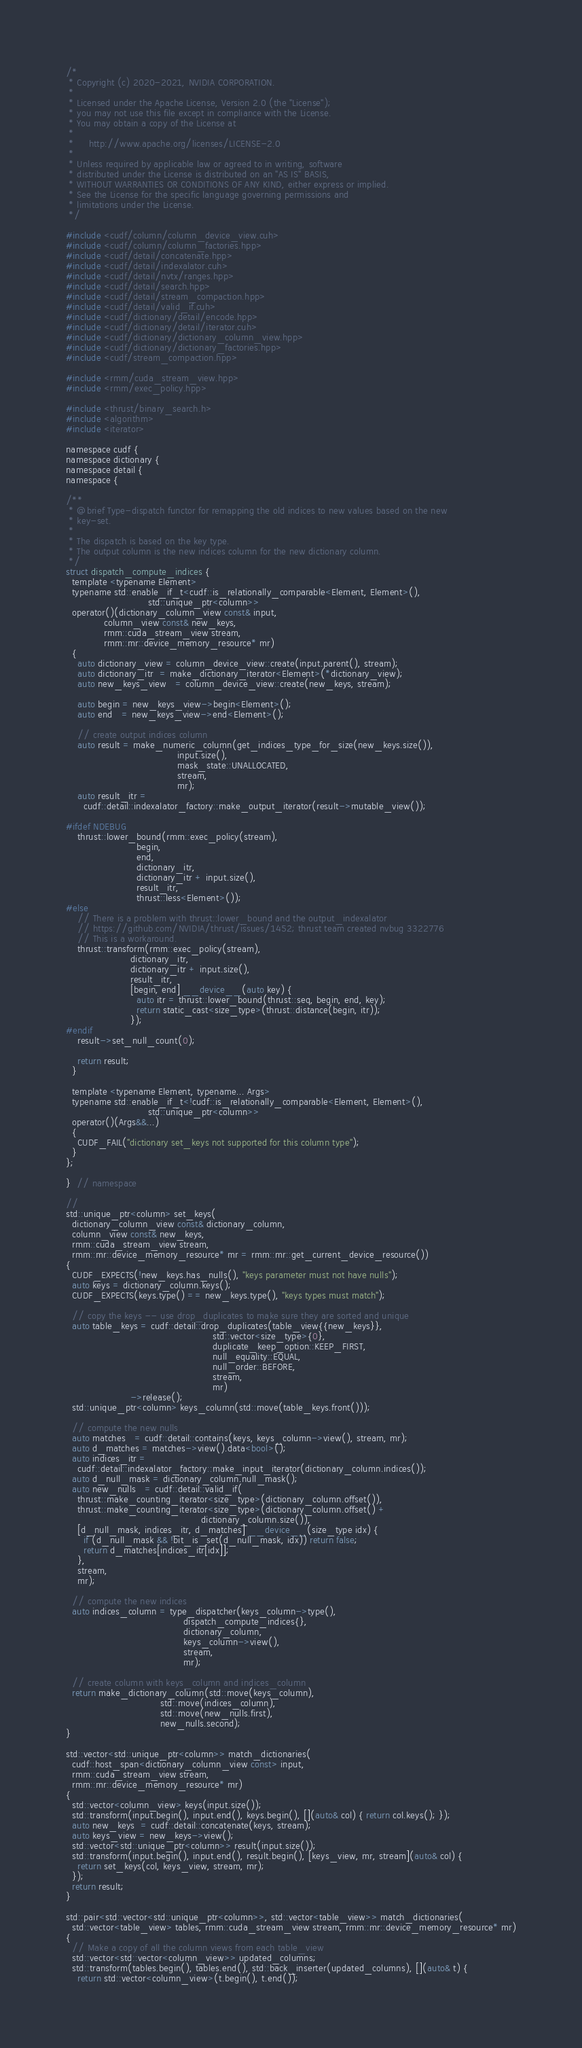<code> <loc_0><loc_0><loc_500><loc_500><_Cuda_>/*
 * Copyright (c) 2020-2021, NVIDIA CORPORATION.
 *
 * Licensed under the Apache License, Version 2.0 (the "License");
 * you may not use this file except in compliance with the License.
 * You may obtain a copy of the License at
 *
 *     http://www.apache.org/licenses/LICENSE-2.0
 *
 * Unless required by applicable law or agreed to in writing, software
 * distributed under the License is distributed on an "AS IS" BASIS,
 * WITHOUT WARRANTIES OR CONDITIONS OF ANY KIND, either express or implied.
 * See the License for the specific language governing permissions and
 * limitations under the License.
 */

#include <cudf/column/column_device_view.cuh>
#include <cudf/column/column_factories.hpp>
#include <cudf/detail/concatenate.hpp>
#include <cudf/detail/indexalator.cuh>
#include <cudf/detail/nvtx/ranges.hpp>
#include <cudf/detail/search.hpp>
#include <cudf/detail/stream_compaction.hpp>
#include <cudf/detail/valid_if.cuh>
#include <cudf/dictionary/detail/encode.hpp>
#include <cudf/dictionary/detail/iterator.cuh>
#include <cudf/dictionary/dictionary_column_view.hpp>
#include <cudf/dictionary/dictionary_factories.hpp>
#include <cudf/stream_compaction.hpp>

#include <rmm/cuda_stream_view.hpp>
#include <rmm/exec_policy.hpp>

#include <thrust/binary_search.h>
#include <algorithm>
#include <iterator>

namespace cudf {
namespace dictionary {
namespace detail {
namespace {

/**
 * @brief Type-dispatch functor for remapping the old indices to new values based on the new
 * key-set.
 *
 * The dispatch is based on the key type.
 * The output column is the new indices column for the new dictionary column.
 */
struct dispatch_compute_indices {
  template <typename Element>
  typename std::enable_if_t<cudf::is_relationally_comparable<Element, Element>(),
                            std::unique_ptr<column>>
  operator()(dictionary_column_view const& input,
             column_view const& new_keys,
             rmm::cuda_stream_view stream,
             rmm::mr::device_memory_resource* mr)
  {
    auto dictionary_view = column_device_view::create(input.parent(), stream);
    auto dictionary_itr  = make_dictionary_iterator<Element>(*dictionary_view);
    auto new_keys_view   = column_device_view::create(new_keys, stream);

    auto begin = new_keys_view->begin<Element>();
    auto end   = new_keys_view->end<Element>();

    // create output indices column
    auto result = make_numeric_column(get_indices_type_for_size(new_keys.size()),
                                      input.size(),
                                      mask_state::UNALLOCATED,
                                      stream,
                                      mr);
    auto result_itr =
      cudf::detail::indexalator_factory::make_output_iterator(result->mutable_view());

#ifdef NDEBUG
    thrust::lower_bound(rmm::exec_policy(stream),
                        begin,
                        end,
                        dictionary_itr,
                        dictionary_itr + input.size(),
                        result_itr,
                        thrust::less<Element>());
#else
    // There is a problem with thrust::lower_bound and the output_indexalator
    // https://github.com/NVIDIA/thrust/issues/1452; thrust team created nvbug 3322776
    // This is a workaround.
    thrust::transform(rmm::exec_policy(stream),
                      dictionary_itr,
                      dictionary_itr + input.size(),
                      result_itr,
                      [begin, end] __device__(auto key) {
                        auto itr = thrust::lower_bound(thrust::seq, begin, end, key);
                        return static_cast<size_type>(thrust::distance(begin, itr));
                      });
#endif
    result->set_null_count(0);

    return result;
  }

  template <typename Element, typename... Args>
  typename std::enable_if_t<!cudf::is_relationally_comparable<Element, Element>(),
                            std::unique_ptr<column>>
  operator()(Args&&...)
  {
    CUDF_FAIL("dictionary set_keys not supported for this column type");
  }
};

}  // namespace

//
std::unique_ptr<column> set_keys(
  dictionary_column_view const& dictionary_column,
  column_view const& new_keys,
  rmm::cuda_stream_view stream,
  rmm::mr::device_memory_resource* mr = rmm::mr::get_current_device_resource())
{
  CUDF_EXPECTS(!new_keys.has_nulls(), "keys parameter must not have nulls");
  auto keys = dictionary_column.keys();
  CUDF_EXPECTS(keys.type() == new_keys.type(), "keys types must match");

  // copy the keys -- use drop_duplicates to make sure they are sorted and unique
  auto table_keys = cudf::detail::drop_duplicates(table_view{{new_keys}},
                                                  std::vector<size_type>{0},
                                                  duplicate_keep_option::KEEP_FIRST,
                                                  null_equality::EQUAL,
                                                  null_order::BEFORE,
                                                  stream,
                                                  mr)
                      ->release();
  std::unique_ptr<column> keys_column(std::move(table_keys.front()));

  // compute the new nulls
  auto matches   = cudf::detail::contains(keys, keys_column->view(), stream, mr);
  auto d_matches = matches->view().data<bool>();
  auto indices_itr =
    cudf::detail::indexalator_factory::make_input_iterator(dictionary_column.indices());
  auto d_null_mask = dictionary_column.null_mask();
  auto new_nulls   = cudf::detail::valid_if(
    thrust::make_counting_iterator<size_type>(dictionary_column.offset()),
    thrust::make_counting_iterator<size_type>(dictionary_column.offset() +
                                              dictionary_column.size()),
    [d_null_mask, indices_itr, d_matches] __device__(size_type idx) {
      if (d_null_mask && !bit_is_set(d_null_mask, idx)) return false;
      return d_matches[indices_itr[idx]];
    },
    stream,
    mr);

  // compute the new indices
  auto indices_column = type_dispatcher(keys_column->type(),
                                        dispatch_compute_indices{},
                                        dictionary_column,
                                        keys_column->view(),
                                        stream,
                                        mr);

  // create column with keys_column and indices_column
  return make_dictionary_column(std::move(keys_column),
                                std::move(indices_column),
                                std::move(new_nulls.first),
                                new_nulls.second);
}

std::vector<std::unique_ptr<column>> match_dictionaries(
  cudf::host_span<dictionary_column_view const> input,
  rmm::cuda_stream_view stream,
  rmm::mr::device_memory_resource* mr)
{
  std::vector<column_view> keys(input.size());
  std::transform(input.begin(), input.end(), keys.begin(), [](auto& col) { return col.keys(); });
  auto new_keys  = cudf::detail::concatenate(keys, stream);
  auto keys_view = new_keys->view();
  std::vector<std::unique_ptr<column>> result(input.size());
  std::transform(input.begin(), input.end(), result.begin(), [keys_view, mr, stream](auto& col) {
    return set_keys(col, keys_view, stream, mr);
  });
  return result;
}

std::pair<std::vector<std::unique_ptr<column>>, std::vector<table_view>> match_dictionaries(
  std::vector<table_view> tables, rmm::cuda_stream_view stream, rmm::mr::device_memory_resource* mr)
{
  // Make a copy of all the column views from each table_view
  std::vector<std::vector<column_view>> updated_columns;
  std::transform(tables.begin(), tables.end(), std::back_inserter(updated_columns), [](auto& t) {
    return std::vector<column_view>(t.begin(), t.end());</code> 